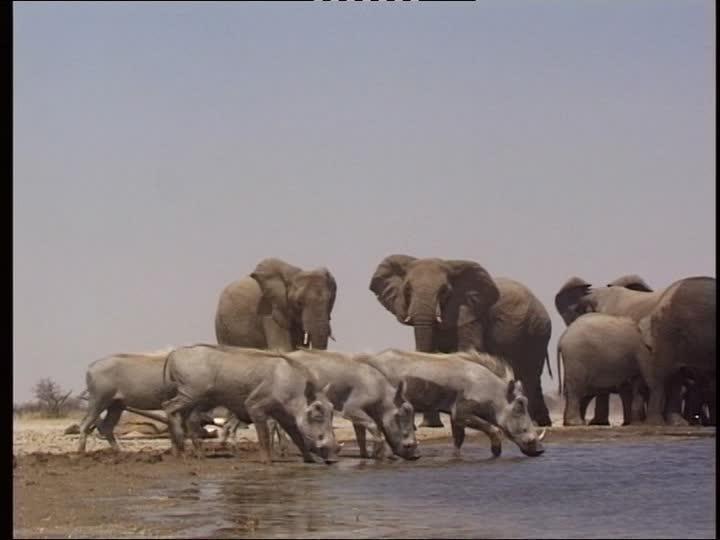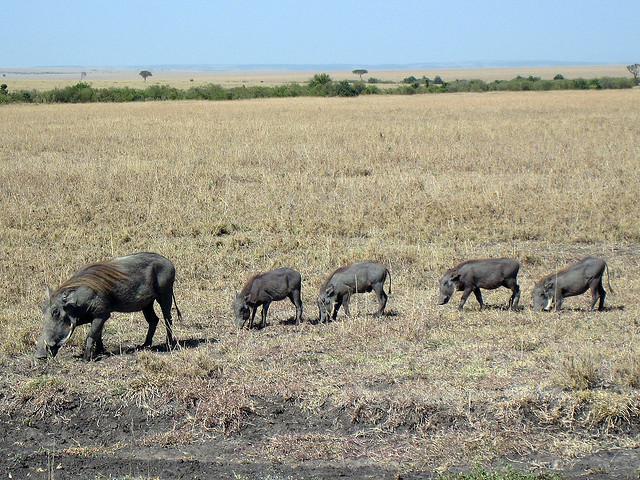The first image is the image on the left, the second image is the image on the right. Given the left and right images, does the statement "There are exactly five animals in the image on the right." hold true? Answer yes or no. Yes. The first image is the image on the left, the second image is the image on the right. Assess this claim about the two images: "In one of the images there is a group of warthogs standing near water.". Correct or not? Answer yes or no. Yes. The first image is the image on the left, the second image is the image on the right. Examine the images to the left and right. Is the description "There are exactly five animals in the image on the right." accurate? Answer yes or no. Yes. The first image is the image on the left, the second image is the image on the right. Examine the images to the left and right. Is the description "There are at least five black animals in the image on the right." accurate? Answer yes or no. Yes. 